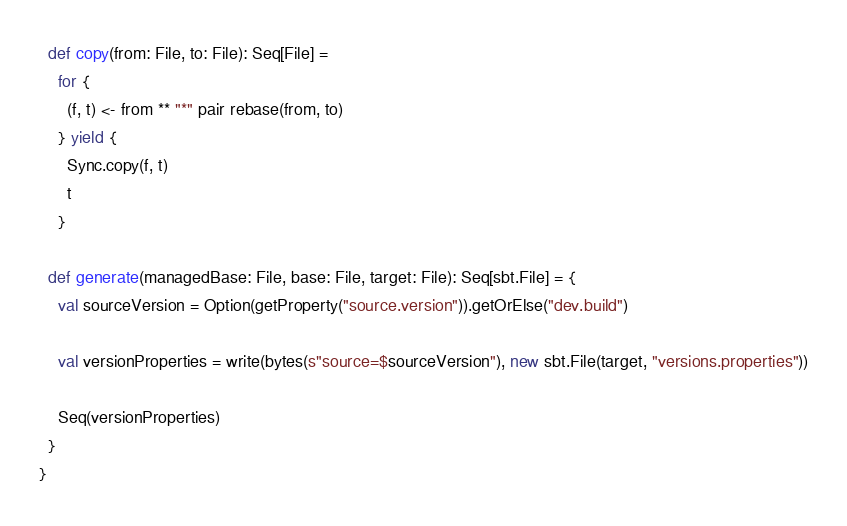Convert code to text. <code><loc_0><loc_0><loc_500><loc_500><_Scala_>  def copy(from: File, to: File): Seq[File] =
    for {
      (f, t) <- from ** "*" pair rebase(from, to)
    } yield {
      Sync.copy(f, t)
      t
    }

  def generate(managedBase: File, base: File, target: File): Seq[sbt.File] = {
    val sourceVersion = Option(getProperty("source.version")).getOrElse("dev.build")

    val versionProperties = write(bytes(s"source=$sourceVersion"), new sbt.File(target, "versions.properties"))

    Seq(versionProperties)
  }
}</code> 